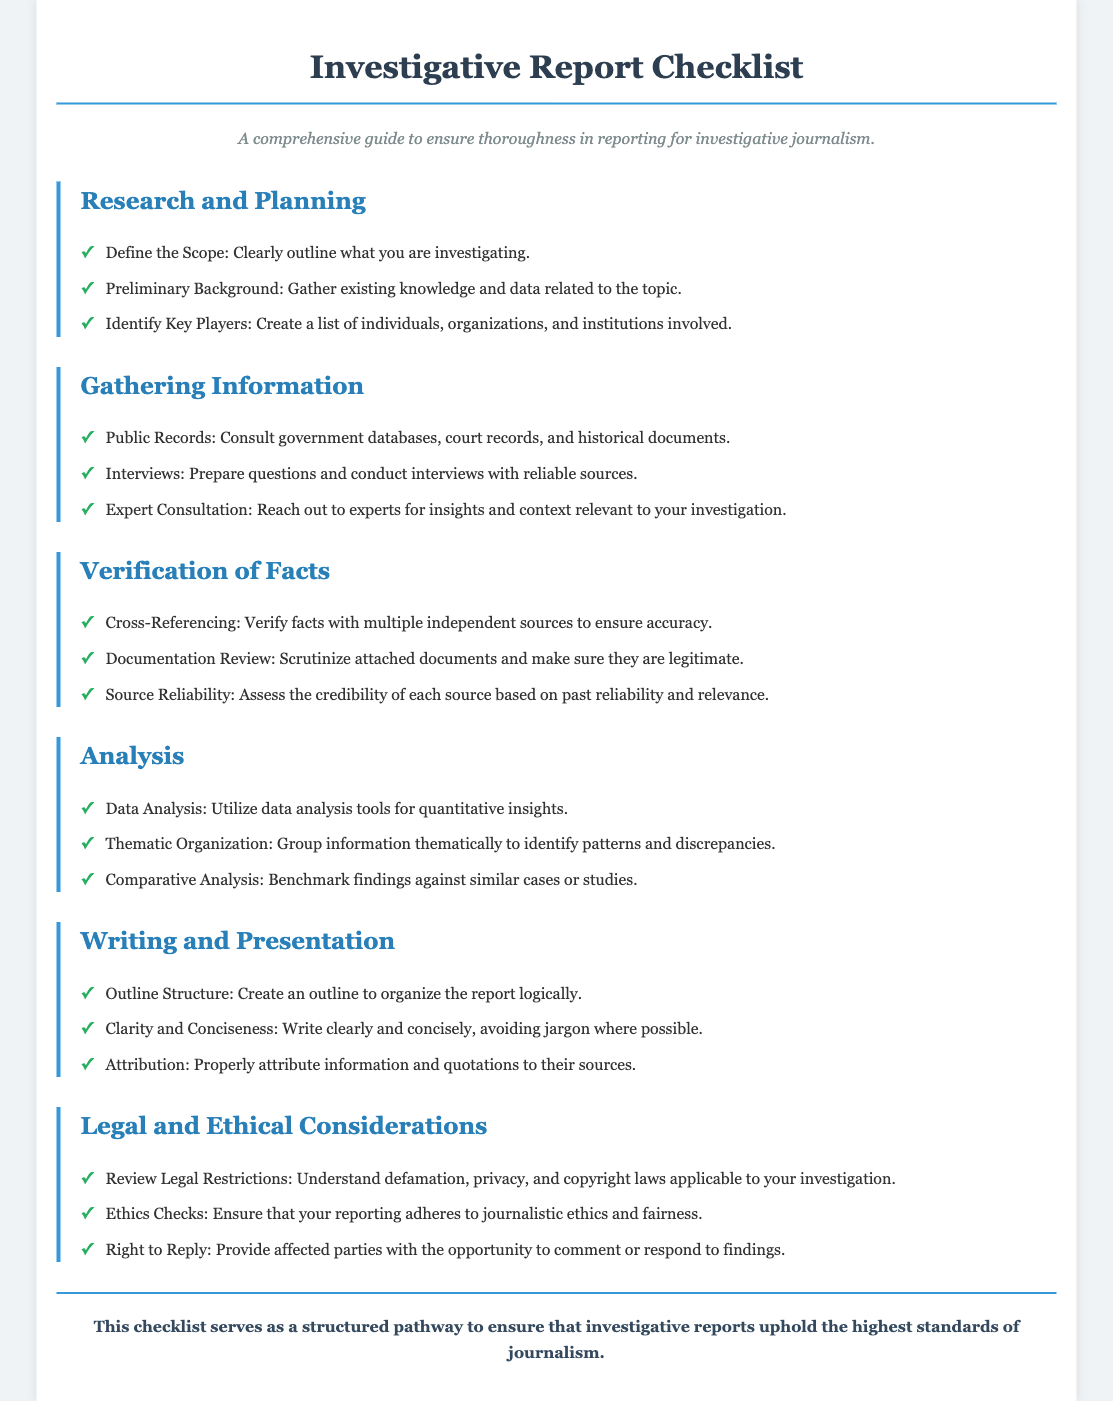What is the title of the document? The title is the main heading of the document, which identifies its content.
Answer: Investigative Report Checklist What is the purpose of the checklist? The purpose is stated in the introductory paragraph, outlining the need for thoroughness in reporting.
Answer: A comprehensive guide to ensure thoroughness in reporting for investigative journalism What should be gathered during the research and planning stage? This involves identifying key steps necessary for laying a strong foundation for the investigation.
Answer: Existing knowledge and data related to the topic How many sections are there in the document? The number of sections can be counted from the headings provided in the document.
Answer: Six Which category includes verifying the credibility of sources? This involves actions taken to ensure the information obtained is accurate and reliable.
Answer: Verification of Facts What is emphasized under Legal and Ethical Considerations? This section outlines essential practices to adhere to while conducting investigations in journalism.
Answer: Understand defamation, privacy, and copyright laws applicable to your investigation What type of analysis is suggested for identifying patterns? This involves organizing gathered information to highlight trends or discrepancies during the investigative process.
Answer: Thematic Organization What follows the writing stage in the investigative process? This refers to the steps taken to prepare the findings for presentation.
Answer: Legal and Ethical Considerations 